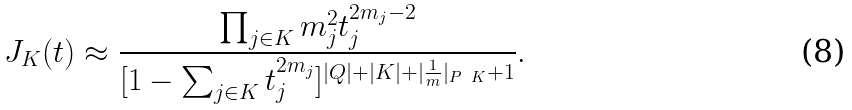Convert formula to latex. <formula><loc_0><loc_0><loc_500><loc_500>J _ { K } ( t ) \approx \frac { \prod _ { j \in K } m _ { j } ^ { 2 } t _ { j } ^ { 2 m _ { j } - 2 } } { [ 1 - \sum _ { j \in K } t _ { j } ^ { 2 m _ { j } } ] ^ { | Q | + | K | + | \frac { 1 } { m } | _ { P \ K } + 1 } } .</formula> 